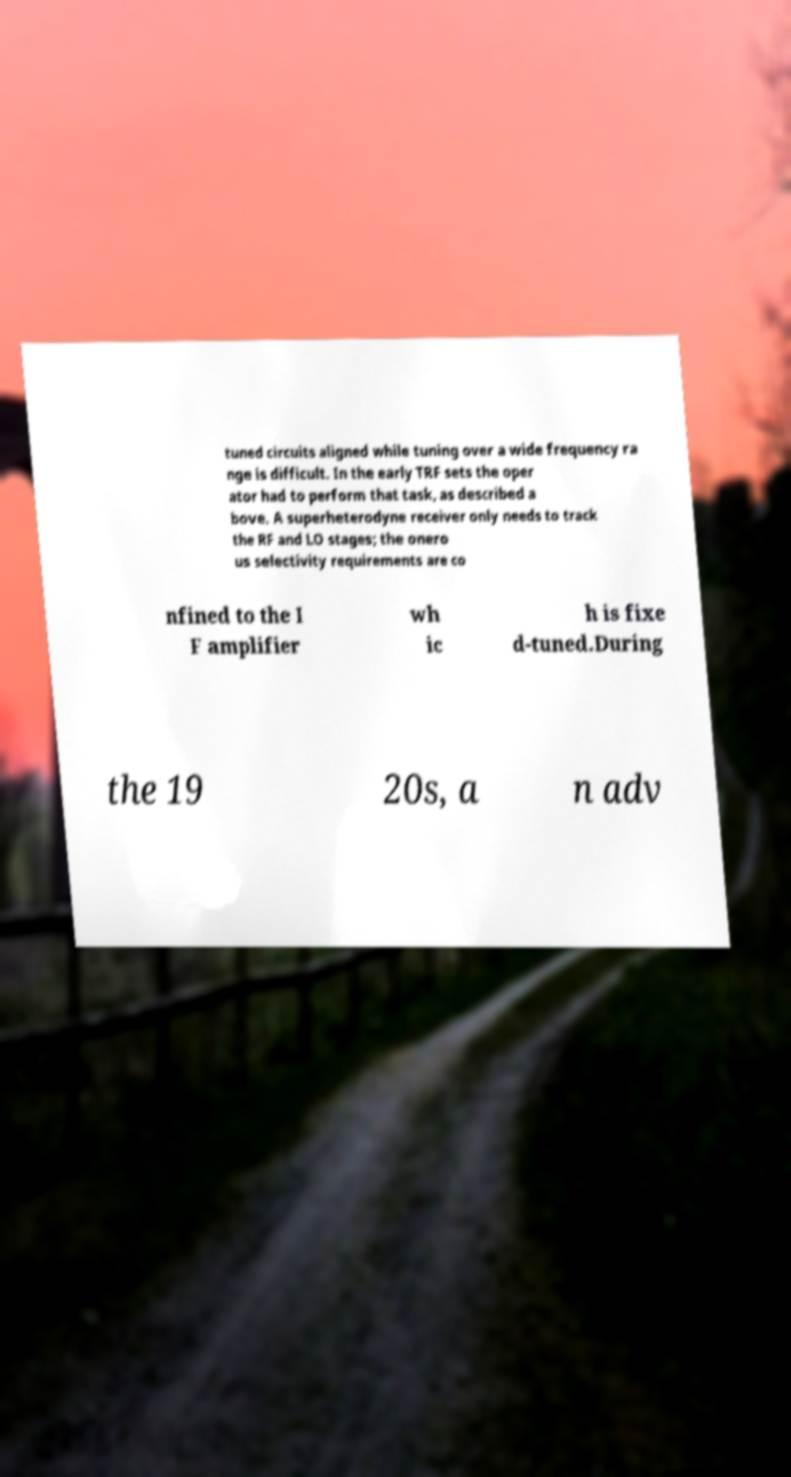Can you accurately transcribe the text from the provided image for me? tuned circuits aligned while tuning over a wide frequency ra nge is difficult. In the early TRF sets the oper ator had to perform that task, as described a bove. A superheterodyne receiver only needs to track the RF and LO stages; the onero us selectivity requirements are co nfined to the I F amplifier wh ic h is fixe d-tuned.During the 19 20s, a n adv 